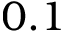Convert formula to latex. <formula><loc_0><loc_0><loc_500><loc_500>0 . 1</formula> 